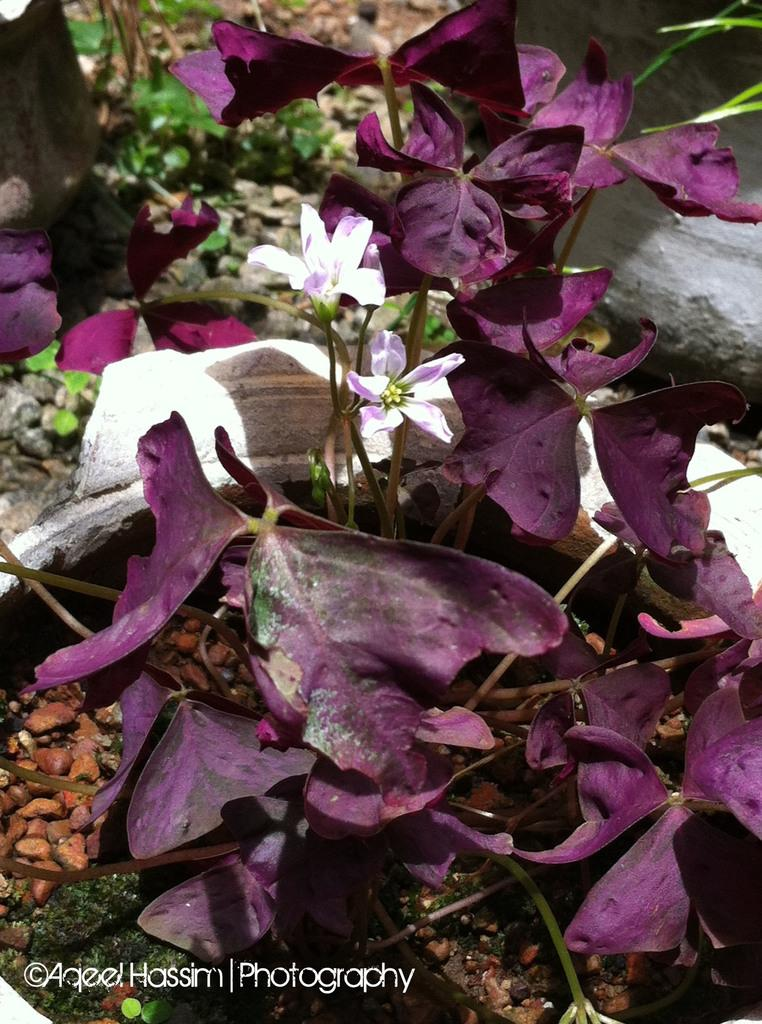What type of plant is in the image? There is a house plant with flowers in the image. Where is the house plant located? The house plant is on the ground. What can be seen in the background of the image? There are stones and grass in the background of the image. What is visible at the bottom of the image? There is text visible at the bottom of the image. How does the house plant contribute to the harmony of the image? The concept of harmony is subjective and cannot be definitively determined from the image. Additionally, the image does not contain any elements that would allow us to assess the harmony of the scene. 